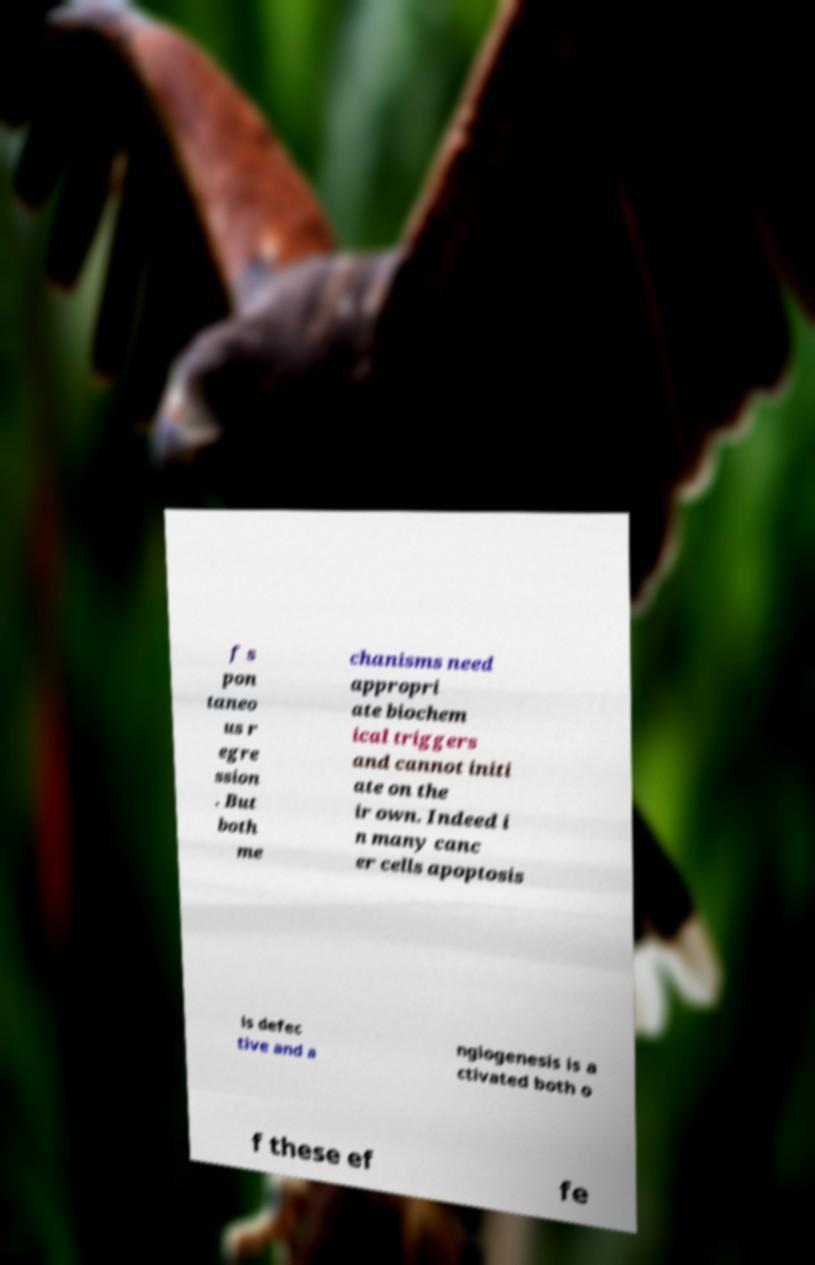For documentation purposes, I need the text within this image transcribed. Could you provide that? f s pon taneo us r egre ssion . But both me chanisms need appropri ate biochem ical triggers and cannot initi ate on the ir own. Indeed i n many canc er cells apoptosis is defec tive and a ngiogenesis is a ctivated both o f these ef fe 